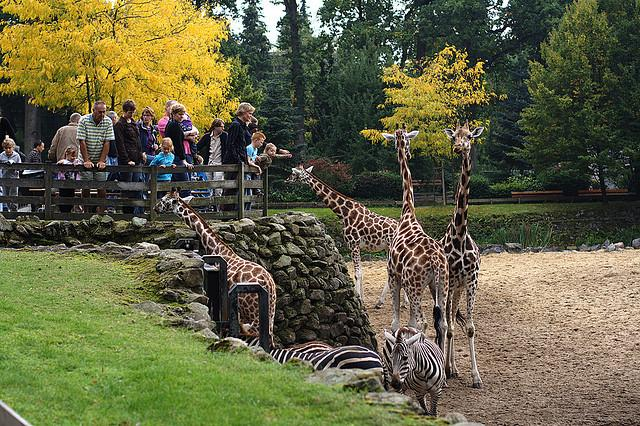What is closest to the giraffe?

Choices:
A) baby eel
B) hat
C) zebra
D) baby zebra 